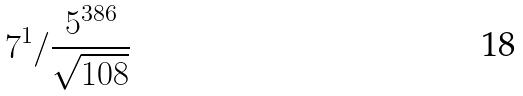<formula> <loc_0><loc_0><loc_500><loc_500>7 ^ { 1 } / \frac { 5 ^ { 3 8 6 } } { \sqrt { 1 0 8 } }</formula> 